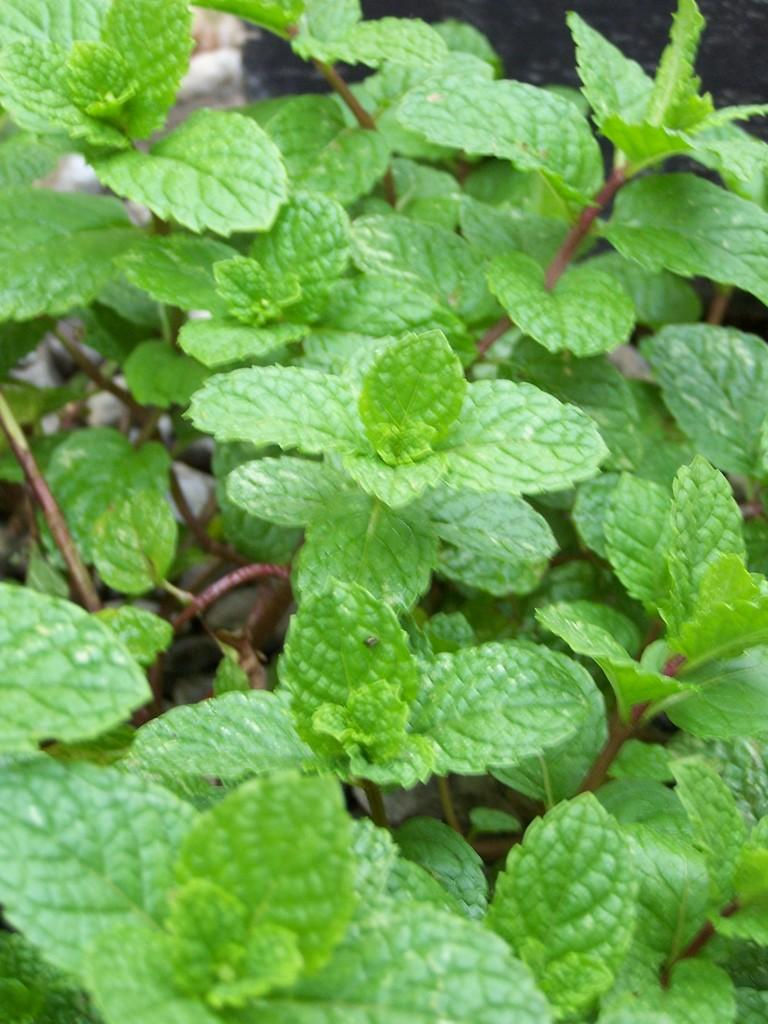What type of living organisms can be seen in the image? Plants can be seen in the image. What color are the leaves of the plants in the image? The leaves of the plants in the image are green. Can you describe the background of the image? The background of the image is blurred. What type of basin can be seen in the image? There is no basin present in the image. Can you describe the behavior of the deer in the image? There are no deer present in the image. 